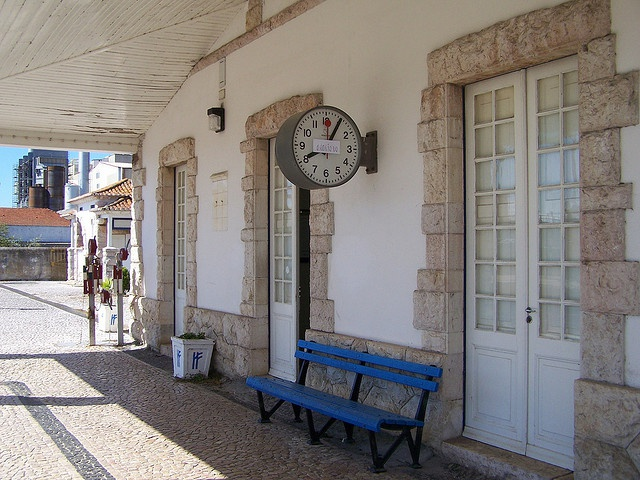Describe the objects in this image and their specific colors. I can see bench in darkgray, black, navy, gray, and blue tones, clock in darkgray, gray, and black tones, and potted plant in darkgray, gray, and black tones in this image. 